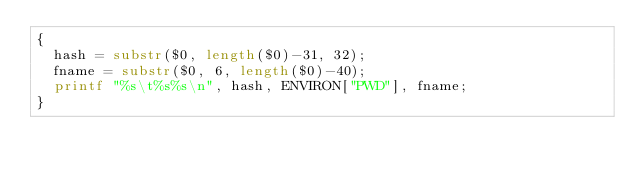Convert code to text. <code><loc_0><loc_0><loc_500><loc_500><_Awk_>{
  hash = substr($0, length($0)-31, 32);
  fname = substr($0, 6, length($0)-40);
  printf "%s\t%s%s\n", hash, ENVIRON["PWD"], fname;
}
</code> 